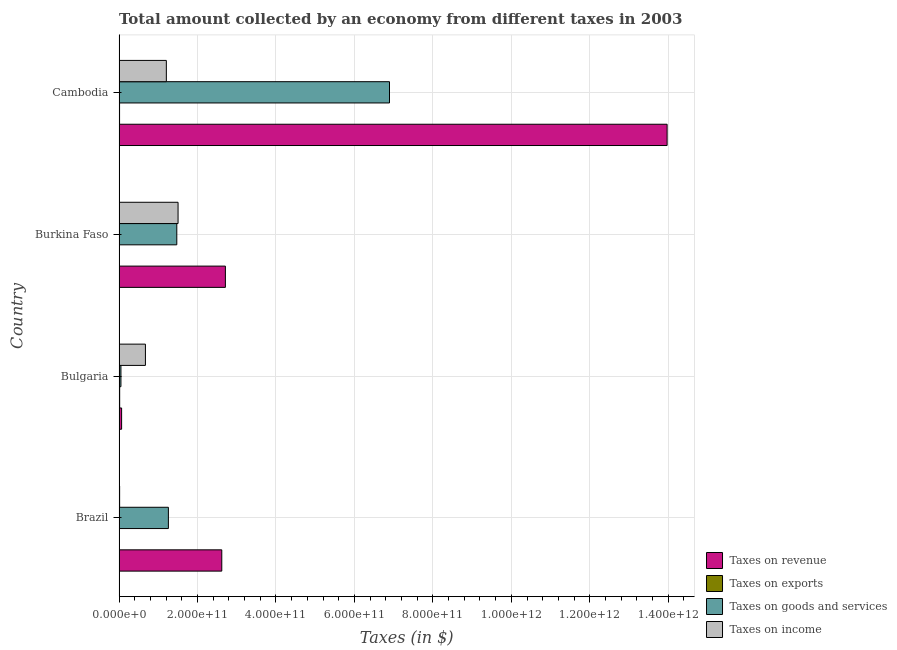How many different coloured bars are there?
Your answer should be very brief. 4. How many groups of bars are there?
Your response must be concise. 4. Are the number of bars on each tick of the Y-axis equal?
Make the answer very short. Yes. How many bars are there on the 4th tick from the top?
Give a very brief answer. 4. What is the label of the 2nd group of bars from the top?
Keep it short and to the point. Burkina Faso. In how many cases, is the number of bars for a given country not equal to the number of legend labels?
Keep it short and to the point. 0. What is the amount collected as tax on exports in Bulgaria?
Your response must be concise. 1.59e+09. Across all countries, what is the maximum amount collected as tax on income?
Your answer should be very brief. 1.50e+11. Across all countries, what is the minimum amount collected as tax on revenue?
Your answer should be very brief. 6.53e+09. In which country was the amount collected as tax on goods maximum?
Your response must be concise. Cambodia. What is the total amount collected as tax on goods in the graph?
Offer a very short reply. 9.67e+11. What is the difference between the amount collected as tax on income in Bulgaria and that in Cambodia?
Provide a short and direct response. -5.33e+1. What is the difference between the amount collected as tax on goods in Brazil and the amount collected as tax on exports in Burkina Faso?
Keep it short and to the point. 1.25e+11. What is the average amount collected as tax on exports per country?
Your answer should be compact. 1.22e+09. What is the difference between the amount collected as tax on goods and amount collected as tax on exports in Brazil?
Your answer should be very brief. 1.25e+11. What is the ratio of the amount collected as tax on goods in Brazil to that in Cambodia?
Keep it short and to the point. 0.18. Is the amount collected as tax on exports in Brazil less than that in Burkina Faso?
Provide a succinct answer. No. Is the difference between the amount collected as tax on exports in Brazil and Cambodia greater than the difference between the amount collected as tax on revenue in Brazil and Cambodia?
Your answer should be compact. Yes. What is the difference between the highest and the second highest amount collected as tax on goods?
Offer a terse response. 5.42e+11. What is the difference between the highest and the lowest amount collected as tax on income?
Give a very brief answer. 1.49e+11. In how many countries, is the amount collected as tax on exports greater than the average amount collected as tax on exports taken over all countries?
Your answer should be compact. 2. Is the sum of the amount collected as tax on exports in Brazil and Burkina Faso greater than the maximum amount collected as tax on income across all countries?
Provide a succinct answer. No. Is it the case that in every country, the sum of the amount collected as tax on exports and amount collected as tax on revenue is greater than the sum of amount collected as tax on goods and amount collected as tax on income?
Offer a very short reply. No. What does the 4th bar from the top in Burkina Faso represents?
Keep it short and to the point. Taxes on revenue. What does the 2nd bar from the bottom in Brazil represents?
Provide a succinct answer. Taxes on exports. How many bars are there?
Your answer should be very brief. 16. Are all the bars in the graph horizontal?
Keep it short and to the point. Yes. How many countries are there in the graph?
Offer a very short reply. 4. What is the difference between two consecutive major ticks on the X-axis?
Give a very brief answer. 2.00e+11. Are the values on the major ticks of X-axis written in scientific E-notation?
Provide a short and direct response. Yes. Does the graph contain any zero values?
Make the answer very short. No. Where does the legend appear in the graph?
Give a very brief answer. Bottom right. How many legend labels are there?
Make the answer very short. 4. How are the legend labels stacked?
Your response must be concise. Vertical. What is the title of the graph?
Ensure brevity in your answer.  Total amount collected by an economy from different taxes in 2003. Does "Industry" appear as one of the legend labels in the graph?
Your response must be concise. No. What is the label or title of the X-axis?
Your response must be concise. Taxes (in $). What is the Taxes (in $) in Taxes on revenue in Brazil?
Keep it short and to the point. 2.62e+11. What is the Taxes (in $) in Taxes on exports in Brazil?
Offer a terse response. 1.16e+09. What is the Taxes (in $) in Taxes on goods and services in Brazil?
Provide a short and direct response. 1.26e+11. What is the Taxes (in $) of Taxes on income in Brazil?
Your answer should be compact. 1.48e+09. What is the Taxes (in $) in Taxes on revenue in Bulgaria?
Your answer should be compact. 6.53e+09. What is the Taxes (in $) in Taxes on exports in Bulgaria?
Offer a very short reply. 1.59e+09. What is the Taxes (in $) of Taxes on goods and services in Bulgaria?
Give a very brief answer. 4.81e+09. What is the Taxes (in $) in Taxes on income in Bulgaria?
Ensure brevity in your answer.  6.72e+1. What is the Taxes (in $) of Taxes on revenue in Burkina Faso?
Give a very brief answer. 2.71e+11. What is the Taxes (in $) in Taxes on exports in Burkina Faso?
Offer a very short reply. 8.56e+08. What is the Taxes (in $) in Taxes on goods and services in Burkina Faso?
Your answer should be very brief. 1.47e+11. What is the Taxes (in $) of Taxes on income in Burkina Faso?
Give a very brief answer. 1.50e+11. What is the Taxes (in $) in Taxes on revenue in Cambodia?
Your answer should be compact. 1.40e+12. What is the Taxes (in $) of Taxes on exports in Cambodia?
Your response must be concise. 1.28e+09. What is the Taxes (in $) in Taxes on goods and services in Cambodia?
Offer a very short reply. 6.89e+11. What is the Taxes (in $) of Taxes on income in Cambodia?
Your response must be concise. 1.21e+11. Across all countries, what is the maximum Taxes (in $) of Taxes on revenue?
Offer a very short reply. 1.40e+12. Across all countries, what is the maximum Taxes (in $) in Taxes on exports?
Make the answer very short. 1.59e+09. Across all countries, what is the maximum Taxes (in $) of Taxes on goods and services?
Your response must be concise. 6.89e+11. Across all countries, what is the maximum Taxes (in $) in Taxes on income?
Keep it short and to the point. 1.50e+11. Across all countries, what is the minimum Taxes (in $) in Taxes on revenue?
Your answer should be compact. 6.53e+09. Across all countries, what is the minimum Taxes (in $) in Taxes on exports?
Provide a short and direct response. 8.56e+08. Across all countries, what is the minimum Taxes (in $) in Taxes on goods and services?
Give a very brief answer. 4.81e+09. Across all countries, what is the minimum Taxes (in $) of Taxes on income?
Your answer should be very brief. 1.48e+09. What is the total Taxes (in $) in Taxes on revenue in the graph?
Offer a terse response. 1.94e+12. What is the total Taxes (in $) of Taxes on exports in the graph?
Provide a short and direct response. 4.88e+09. What is the total Taxes (in $) in Taxes on goods and services in the graph?
Your answer should be compact. 9.67e+11. What is the total Taxes (in $) of Taxes on income in the graph?
Keep it short and to the point. 3.40e+11. What is the difference between the Taxes (in $) in Taxes on revenue in Brazil and that in Bulgaria?
Your response must be concise. 2.55e+11. What is the difference between the Taxes (in $) of Taxes on exports in Brazil and that in Bulgaria?
Provide a short and direct response. -4.32e+08. What is the difference between the Taxes (in $) in Taxes on goods and services in Brazil and that in Bulgaria?
Ensure brevity in your answer.  1.21e+11. What is the difference between the Taxes (in $) of Taxes on income in Brazil and that in Bulgaria?
Your answer should be compact. -6.58e+1. What is the difference between the Taxes (in $) of Taxes on revenue in Brazil and that in Burkina Faso?
Offer a terse response. -9.21e+09. What is the difference between the Taxes (in $) of Taxes on exports in Brazil and that in Burkina Faso?
Provide a succinct answer. 3.00e+08. What is the difference between the Taxes (in $) of Taxes on goods and services in Brazil and that in Burkina Faso?
Provide a short and direct response. -2.14e+1. What is the difference between the Taxes (in $) in Taxes on income in Brazil and that in Burkina Faso?
Offer a very short reply. -1.49e+11. What is the difference between the Taxes (in $) in Taxes on revenue in Brazil and that in Cambodia?
Your answer should be very brief. -1.14e+12. What is the difference between the Taxes (in $) in Taxes on exports in Brazil and that in Cambodia?
Make the answer very short. -1.27e+08. What is the difference between the Taxes (in $) in Taxes on goods and services in Brazil and that in Cambodia?
Offer a very short reply. -5.64e+11. What is the difference between the Taxes (in $) of Taxes on income in Brazil and that in Cambodia?
Ensure brevity in your answer.  -1.19e+11. What is the difference between the Taxes (in $) in Taxes on revenue in Bulgaria and that in Burkina Faso?
Give a very brief answer. -2.65e+11. What is the difference between the Taxes (in $) in Taxes on exports in Bulgaria and that in Burkina Faso?
Offer a very short reply. 7.32e+08. What is the difference between the Taxes (in $) in Taxes on goods and services in Bulgaria and that in Burkina Faso?
Offer a very short reply. -1.42e+11. What is the difference between the Taxes (in $) of Taxes on income in Bulgaria and that in Burkina Faso?
Offer a terse response. -8.32e+1. What is the difference between the Taxes (in $) in Taxes on revenue in Bulgaria and that in Cambodia?
Offer a very short reply. -1.39e+12. What is the difference between the Taxes (in $) of Taxes on exports in Bulgaria and that in Cambodia?
Your response must be concise. 3.05e+08. What is the difference between the Taxes (in $) of Taxes on goods and services in Bulgaria and that in Cambodia?
Your answer should be very brief. -6.85e+11. What is the difference between the Taxes (in $) of Taxes on income in Bulgaria and that in Cambodia?
Keep it short and to the point. -5.33e+1. What is the difference between the Taxes (in $) in Taxes on revenue in Burkina Faso and that in Cambodia?
Provide a short and direct response. -1.13e+12. What is the difference between the Taxes (in $) in Taxes on exports in Burkina Faso and that in Cambodia?
Keep it short and to the point. -4.27e+08. What is the difference between the Taxes (in $) in Taxes on goods and services in Burkina Faso and that in Cambodia?
Your answer should be very brief. -5.42e+11. What is the difference between the Taxes (in $) in Taxes on income in Burkina Faso and that in Cambodia?
Your response must be concise. 2.99e+1. What is the difference between the Taxes (in $) of Taxes on revenue in Brazil and the Taxes (in $) of Taxes on exports in Bulgaria?
Keep it short and to the point. 2.60e+11. What is the difference between the Taxes (in $) of Taxes on revenue in Brazil and the Taxes (in $) of Taxes on goods and services in Bulgaria?
Provide a succinct answer. 2.57e+11. What is the difference between the Taxes (in $) of Taxes on revenue in Brazil and the Taxes (in $) of Taxes on income in Bulgaria?
Offer a terse response. 1.95e+11. What is the difference between the Taxes (in $) in Taxes on exports in Brazil and the Taxes (in $) in Taxes on goods and services in Bulgaria?
Make the answer very short. -3.66e+09. What is the difference between the Taxes (in $) of Taxes on exports in Brazil and the Taxes (in $) of Taxes on income in Bulgaria?
Keep it short and to the point. -6.61e+1. What is the difference between the Taxes (in $) of Taxes on goods and services in Brazil and the Taxes (in $) of Taxes on income in Bulgaria?
Ensure brevity in your answer.  5.85e+1. What is the difference between the Taxes (in $) in Taxes on revenue in Brazil and the Taxes (in $) in Taxes on exports in Burkina Faso?
Your answer should be compact. 2.61e+11. What is the difference between the Taxes (in $) of Taxes on revenue in Brazil and the Taxes (in $) of Taxes on goods and services in Burkina Faso?
Keep it short and to the point. 1.15e+11. What is the difference between the Taxes (in $) of Taxes on revenue in Brazil and the Taxes (in $) of Taxes on income in Burkina Faso?
Give a very brief answer. 1.11e+11. What is the difference between the Taxes (in $) in Taxes on exports in Brazil and the Taxes (in $) in Taxes on goods and services in Burkina Faso?
Your answer should be compact. -1.46e+11. What is the difference between the Taxes (in $) of Taxes on exports in Brazil and the Taxes (in $) of Taxes on income in Burkina Faso?
Offer a terse response. -1.49e+11. What is the difference between the Taxes (in $) of Taxes on goods and services in Brazil and the Taxes (in $) of Taxes on income in Burkina Faso?
Provide a short and direct response. -2.46e+1. What is the difference between the Taxes (in $) of Taxes on revenue in Brazil and the Taxes (in $) of Taxes on exports in Cambodia?
Keep it short and to the point. 2.61e+11. What is the difference between the Taxes (in $) of Taxes on revenue in Brazil and the Taxes (in $) of Taxes on goods and services in Cambodia?
Your answer should be compact. -4.28e+11. What is the difference between the Taxes (in $) of Taxes on revenue in Brazil and the Taxes (in $) of Taxes on income in Cambodia?
Ensure brevity in your answer.  1.41e+11. What is the difference between the Taxes (in $) of Taxes on exports in Brazil and the Taxes (in $) of Taxes on goods and services in Cambodia?
Give a very brief answer. -6.88e+11. What is the difference between the Taxes (in $) in Taxes on exports in Brazil and the Taxes (in $) in Taxes on income in Cambodia?
Your answer should be compact. -1.19e+11. What is the difference between the Taxes (in $) of Taxes on goods and services in Brazil and the Taxes (in $) of Taxes on income in Cambodia?
Your answer should be very brief. 5.22e+09. What is the difference between the Taxes (in $) of Taxes on revenue in Bulgaria and the Taxes (in $) of Taxes on exports in Burkina Faso?
Ensure brevity in your answer.  5.67e+09. What is the difference between the Taxes (in $) of Taxes on revenue in Bulgaria and the Taxes (in $) of Taxes on goods and services in Burkina Faso?
Provide a short and direct response. -1.41e+11. What is the difference between the Taxes (in $) in Taxes on revenue in Bulgaria and the Taxes (in $) in Taxes on income in Burkina Faso?
Keep it short and to the point. -1.44e+11. What is the difference between the Taxes (in $) in Taxes on exports in Bulgaria and the Taxes (in $) in Taxes on goods and services in Burkina Faso?
Offer a very short reply. -1.46e+11. What is the difference between the Taxes (in $) of Taxes on exports in Bulgaria and the Taxes (in $) of Taxes on income in Burkina Faso?
Your response must be concise. -1.49e+11. What is the difference between the Taxes (in $) in Taxes on goods and services in Bulgaria and the Taxes (in $) in Taxes on income in Burkina Faso?
Your answer should be compact. -1.46e+11. What is the difference between the Taxes (in $) of Taxes on revenue in Bulgaria and the Taxes (in $) of Taxes on exports in Cambodia?
Your answer should be compact. 5.24e+09. What is the difference between the Taxes (in $) of Taxes on revenue in Bulgaria and the Taxes (in $) of Taxes on goods and services in Cambodia?
Provide a succinct answer. -6.83e+11. What is the difference between the Taxes (in $) in Taxes on revenue in Bulgaria and the Taxes (in $) in Taxes on income in Cambodia?
Provide a succinct answer. -1.14e+11. What is the difference between the Taxes (in $) in Taxes on exports in Bulgaria and the Taxes (in $) in Taxes on goods and services in Cambodia?
Your response must be concise. -6.88e+11. What is the difference between the Taxes (in $) of Taxes on exports in Bulgaria and the Taxes (in $) of Taxes on income in Cambodia?
Your answer should be compact. -1.19e+11. What is the difference between the Taxes (in $) in Taxes on goods and services in Bulgaria and the Taxes (in $) in Taxes on income in Cambodia?
Make the answer very short. -1.16e+11. What is the difference between the Taxes (in $) in Taxes on revenue in Burkina Faso and the Taxes (in $) in Taxes on exports in Cambodia?
Ensure brevity in your answer.  2.70e+11. What is the difference between the Taxes (in $) of Taxes on revenue in Burkina Faso and the Taxes (in $) of Taxes on goods and services in Cambodia?
Provide a succinct answer. -4.18e+11. What is the difference between the Taxes (in $) in Taxes on revenue in Burkina Faso and the Taxes (in $) in Taxes on income in Cambodia?
Give a very brief answer. 1.51e+11. What is the difference between the Taxes (in $) in Taxes on exports in Burkina Faso and the Taxes (in $) in Taxes on goods and services in Cambodia?
Your response must be concise. -6.89e+11. What is the difference between the Taxes (in $) in Taxes on exports in Burkina Faso and the Taxes (in $) in Taxes on income in Cambodia?
Offer a terse response. -1.20e+11. What is the difference between the Taxes (in $) in Taxes on goods and services in Burkina Faso and the Taxes (in $) in Taxes on income in Cambodia?
Your answer should be compact. 2.67e+1. What is the average Taxes (in $) of Taxes on revenue per country?
Offer a very short reply. 4.84e+11. What is the average Taxes (in $) in Taxes on exports per country?
Provide a succinct answer. 1.22e+09. What is the average Taxes (in $) in Taxes on goods and services per country?
Keep it short and to the point. 2.42e+11. What is the average Taxes (in $) of Taxes on income per country?
Provide a short and direct response. 8.49e+1. What is the difference between the Taxes (in $) of Taxes on revenue and Taxes (in $) of Taxes on exports in Brazil?
Keep it short and to the point. 2.61e+11. What is the difference between the Taxes (in $) in Taxes on revenue and Taxes (in $) in Taxes on goods and services in Brazil?
Give a very brief answer. 1.36e+11. What is the difference between the Taxes (in $) in Taxes on revenue and Taxes (in $) in Taxes on income in Brazil?
Offer a very short reply. 2.60e+11. What is the difference between the Taxes (in $) of Taxes on exports and Taxes (in $) of Taxes on goods and services in Brazil?
Your answer should be compact. -1.25e+11. What is the difference between the Taxes (in $) of Taxes on exports and Taxes (in $) of Taxes on income in Brazil?
Your answer should be very brief. -3.21e+08. What is the difference between the Taxes (in $) of Taxes on goods and services and Taxes (in $) of Taxes on income in Brazil?
Your answer should be very brief. 1.24e+11. What is the difference between the Taxes (in $) of Taxes on revenue and Taxes (in $) of Taxes on exports in Bulgaria?
Ensure brevity in your answer.  4.94e+09. What is the difference between the Taxes (in $) of Taxes on revenue and Taxes (in $) of Taxes on goods and services in Bulgaria?
Your answer should be very brief. 1.71e+09. What is the difference between the Taxes (in $) in Taxes on revenue and Taxes (in $) in Taxes on income in Bulgaria?
Offer a terse response. -6.07e+1. What is the difference between the Taxes (in $) in Taxes on exports and Taxes (in $) in Taxes on goods and services in Bulgaria?
Give a very brief answer. -3.22e+09. What is the difference between the Taxes (in $) of Taxes on exports and Taxes (in $) of Taxes on income in Bulgaria?
Give a very brief answer. -6.57e+1. What is the difference between the Taxes (in $) of Taxes on goods and services and Taxes (in $) of Taxes on income in Bulgaria?
Your answer should be compact. -6.24e+1. What is the difference between the Taxes (in $) in Taxes on revenue and Taxes (in $) in Taxes on exports in Burkina Faso?
Your answer should be compact. 2.70e+11. What is the difference between the Taxes (in $) of Taxes on revenue and Taxes (in $) of Taxes on goods and services in Burkina Faso?
Ensure brevity in your answer.  1.24e+11. What is the difference between the Taxes (in $) in Taxes on revenue and Taxes (in $) in Taxes on income in Burkina Faso?
Give a very brief answer. 1.21e+11. What is the difference between the Taxes (in $) in Taxes on exports and Taxes (in $) in Taxes on goods and services in Burkina Faso?
Keep it short and to the point. -1.46e+11. What is the difference between the Taxes (in $) of Taxes on exports and Taxes (in $) of Taxes on income in Burkina Faso?
Your answer should be compact. -1.50e+11. What is the difference between the Taxes (in $) of Taxes on goods and services and Taxes (in $) of Taxes on income in Burkina Faso?
Make the answer very short. -3.21e+09. What is the difference between the Taxes (in $) of Taxes on revenue and Taxes (in $) of Taxes on exports in Cambodia?
Provide a short and direct response. 1.40e+12. What is the difference between the Taxes (in $) of Taxes on revenue and Taxes (in $) of Taxes on goods and services in Cambodia?
Ensure brevity in your answer.  7.08e+11. What is the difference between the Taxes (in $) of Taxes on revenue and Taxes (in $) of Taxes on income in Cambodia?
Ensure brevity in your answer.  1.28e+12. What is the difference between the Taxes (in $) in Taxes on exports and Taxes (in $) in Taxes on goods and services in Cambodia?
Your answer should be very brief. -6.88e+11. What is the difference between the Taxes (in $) in Taxes on exports and Taxes (in $) in Taxes on income in Cambodia?
Provide a succinct answer. -1.19e+11. What is the difference between the Taxes (in $) of Taxes on goods and services and Taxes (in $) of Taxes on income in Cambodia?
Ensure brevity in your answer.  5.69e+11. What is the ratio of the Taxes (in $) of Taxes on revenue in Brazil to that in Bulgaria?
Provide a short and direct response. 40.12. What is the ratio of the Taxes (in $) in Taxes on exports in Brazil to that in Bulgaria?
Provide a succinct answer. 0.73. What is the ratio of the Taxes (in $) of Taxes on goods and services in Brazil to that in Bulgaria?
Ensure brevity in your answer.  26.13. What is the ratio of the Taxes (in $) in Taxes on income in Brazil to that in Bulgaria?
Keep it short and to the point. 0.02. What is the ratio of the Taxes (in $) in Taxes on revenue in Brazil to that in Burkina Faso?
Your answer should be very brief. 0.97. What is the ratio of the Taxes (in $) in Taxes on exports in Brazil to that in Burkina Faso?
Your answer should be compact. 1.35. What is the ratio of the Taxes (in $) in Taxes on goods and services in Brazil to that in Burkina Faso?
Keep it short and to the point. 0.85. What is the ratio of the Taxes (in $) in Taxes on income in Brazil to that in Burkina Faso?
Offer a terse response. 0.01. What is the ratio of the Taxes (in $) of Taxes on revenue in Brazil to that in Cambodia?
Your answer should be compact. 0.19. What is the ratio of the Taxes (in $) in Taxes on exports in Brazil to that in Cambodia?
Your answer should be compact. 0.9. What is the ratio of the Taxes (in $) in Taxes on goods and services in Brazil to that in Cambodia?
Ensure brevity in your answer.  0.18. What is the ratio of the Taxes (in $) in Taxes on income in Brazil to that in Cambodia?
Your answer should be compact. 0.01. What is the ratio of the Taxes (in $) in Taxes on revenue in Bulgaria to that in Burkina Faso?
Ensure brevity in your answer.  0.02. What is the ratio of the Taxes (in $) in Taxes on exports in Bulgaria to that in Burkina Faso?
Give a very brief answer. 1.86. What is the ratio of the Taxes (in $) of Taxes on goods and services in Bulgaria to that in Burkina Faso?
Offer a terse response. 0.03. What is the ratio of the Taxes (in $) in Taxes on income in Bulgaria to that in Burkina Faso?
Ensure brevity in your answer.  0.45. What is the ratio of the Taxes (in $) of Taxes on revenue in Bulgaria to that in Cambodia?
Your answer should be compact. 0. What is the ratio of the Taxes (in $) of Taxes on exports in Bulgaria to that in Cambodia?
Offer a terse response. 1.24. What is the ratio of the Taxes (in $) of Taxes on goods and services in Bulgaria to that in Cambodia?
Make the answer very short. 0.01. What is the ratio of the Taxes (in $) in Taxes on income in Bulgaria to that in Cambodia?
Give a very brief answer. 0.56. What is the ratio of the Taxes (in $) of Taxes on revenue in Burkina Faso to that in Cambodia?
Provide a succinct answer. 0.19. What is the ratio of the Taxes (in $) in Taxes on exports in Burkina Faso to that in Cambodia?
Offer a terse response. 0.67. What is the ratio of the Taxes (in $) of Taxes on goods and services in Burkina Faso to that in Cambodia?
Your answer should be very brief. 0.21. What is the ratio of the Taxes (in $) in Taxes on income in Burkina Faso to that in Cambodia?
Your response must be concise. 1.25. What is the difference between the highest and the second highest Taxes (in $) of Taxes on revenue?
Keep it short and to the point. 1.13e+12. What is the difference between the highest and the second highest Taxes (in $) in Taxes on exports?
Offer a very short reply. 3.05e+08. What is the difference between the highest and the second highest Taxes (in $) of Taxes on goods and services?
Provide a succinct answer. 5.42e+11. What is the difference between the highest and the second highest Taxes (in $) of Taxes on income?
Make the answer very short. 2.99e+1. What is the difference between the highest and the lowest Taxes (in $) in Taxes on revenue?
Ensure brevity in your answer.  1.39e+12. What is the difference between the highest and the lowest Taxes (in $) of Taxes on exports?
Your response must be concise. 7.32e+08. What is the difference between the highest and the lowest Taxes (in $) in Taxes on goods and services?
Offer a terse response. 6.85e+11. What is the difference between the highest and the lowest Taxes (in $) in Taxes on income?
Offer a very short reply. 1.49e+11. 